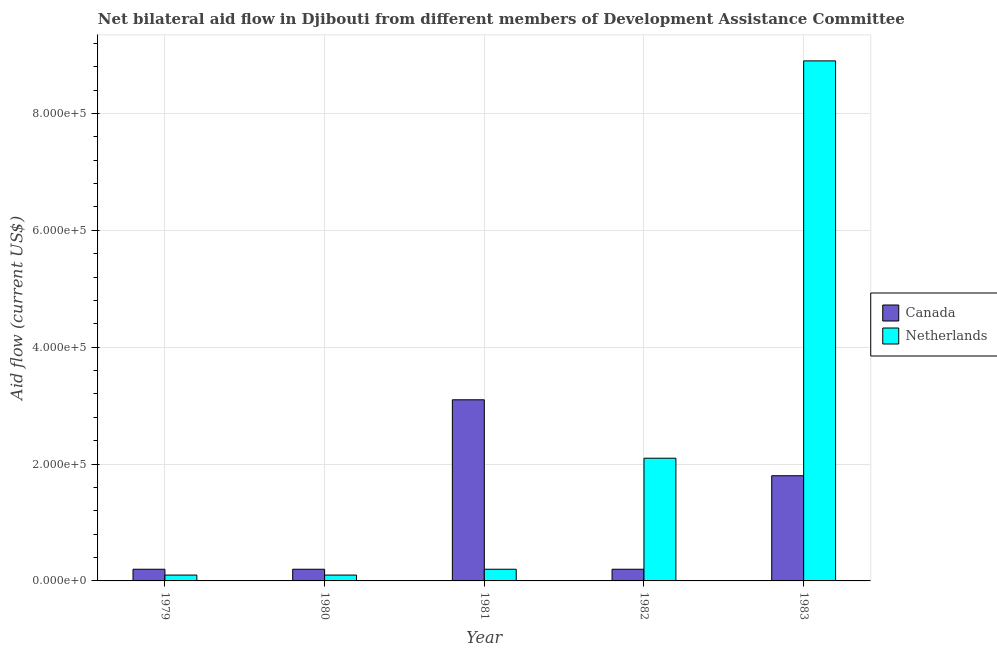How many different coloured bars are there?
Provide a succinct answer. 2. How many groups of bars are there?
Your answer should be compact. 5. Are the number of bars per tick equal to the number of legend labels?
Your answer should be very brief. Yes. Are the number of bars on each tick of the X-axis equal?
Give a very brief answer. Yes. In how many cases, is the number of bars for a given year not equal to the number of legend labels?
Offer a terse response. 0. What is the amount of aid given by netherlands in 1980?
Your answer should be very brief. 10000. Across all years, what is the maximum amount of aid given by netherlands?
Provide a succinct answer. 8.90e+05. Across all years, what is the minimum amount of aid given by canada?
Keep it short and to the point. 2.00e+04. In which year was the amount of aid given by canada maximum?
Ensure brevity in your answer.  1981. In which year was the amount of aid given by netherlands minimum?
Ensure brevity in your answer.  1979. What is the total amount of aid given by netherlands in the graph?
Your answer should be compact. 1.14e+06. What is the difference between the amount of aid given by canada in 1980 and the amount of aid given by netherlands in 1983?
Offer a terse response. -1.60e+05. What is the average amount of aid given by netherlands per year?
Your answer should be compact. 2.28e+05. In the year 1979, what is the difference between the amount of aid given by canada and amount of aid given by netherlands?
Offer a terse response. 0. In how many years, is the amount of aid given by canada greater than 320000 US$?
Provide a succinct answer. 0. What is the ratio of the amount of aid given by netherlands in 1979 to that in 1981?
Make the answer very short. 0.5. Is the amount of aid given by canada in 1982 less than that in 1983?
Give a very brief answer. Yes. What is the difference between the highest and the second highest amount of aid given by netherlands?
Offer a very short reply. 6.80e+05. What is the difference between the highest and the lowest amount of aid given by canada?
Keep it short and to the point. 2.90e+05. In how many years, is the amount of aid given by canada greater than the average amount of aid given by canada taken over all years?
Provide a short and direct response. 2. What does the 2nd bar from the left in 1982 represents?
Keep it short and to the point. Netherlands. What does the 1st bar from the right in 1980 represents?
Your response must be concise. Netherlands. Are all the bars in the graph horizontal?
Provide a short and direct response. No. How many years are there in the graph?
Give a very brief answer. 5. Does the graph contain grids?
Your response must be concise. Yes. What is the title of the graph?
Offer a terse response. Net bilateral aid flow in Djibouti from different members of Development Assistance Committee. Does "Female labourers" appear as one of the legend labels in the graph?
Offer a terse response. No. What is the label or title of the Y-axis?
Make the answer very short. Aid flow (current US$). What is the Aid flow (current US$) of Netherlands in 1979?
Your answer should be very brief. 10000. What is the Aid flow (current US$) of Netherlands in 1981?
Ensure brevity in your answer.  2.00e+04. What is the Aid flow (current US$) in Canada in 1982?
Your answer should be compact. 2.00e+04. What is the Aid flow (current US$) of Netherlands in 1982?
Ensure brevity in your answer.  2.10e+05. What is the Aid flow (current US$) in Netherlands in 1983?
Ensure brevity in your answer.  8.90e+05. Across all years, what is the maximum Aid flow (current US$) of Canada?
Offer a terse response. 3.10e+05. Across all years, what is the maximum Aid flow (current US$) in Netherlands?
Offer a terse response. 8.90e+05. Across all years, what is the minimum Aid flow (current US$) of Canada?
Your response must be concise. 2.00e+04. What is the total Aid flow (current US$) of Netherlands in the graph?
Offer a terse response. 1.14e+06. What is the difference between the Aid flow (current US$) of Canada in 1979 and that in 1980?
Ensure brevity in your answer.  0. What is the difference between the Aid flow (current US$) in Netherlands in 1979 and that in 1980?
Offer a terse response. 0. What is the difference between the Aid flow (current US$) in Canada in 1979 and that in 1981?
Keep it short and to the point. -2.90e+05. What is the difference between the Aid flow (current US$) in Netherlands in 1979 and that in 1982?
Keep it short and to the point. -2.00e+05. What is the difference between the Aid flow (current US$) in Canada in 1979 and that in 1983?
Your answer should be very brief. -1.60e+05. What is the difference between the Aid flow (current US$) in Netherlands in 1979 and that in 1983?
Your answer should be compact. -8.80e+05. What is the difference between the Aid flow (current US$) in Netherlands in 1980 and that in 1981?
Keep it short and to the point. -10000. What is the difference between the Aid flow (current US$) of Canada in 1980 and that in 1982?
Your response must be concise. 0. What is the difference between the Aid flow (current US$) of Canada in 1980 and that in 1983?
Offer a very short reply. -1.60e+05. What is the difference between the Aid flow (current US$) of Netherlands in 1980 and that in 1983?
Ensure brevity in your answer.  -8.80e+05. What is the difference between the Aid flow (current US$) in Netherlands in 1981 and that in 1982?
Make the answer very short. -1.90e+05. What is the difference between the Aid flow (current US$) in Canada in 1981 and that in 1983?
Ensure brevity in your answer.  1.30e+05. What is the difference between the Aid flow (current US$) of Netherlands in 1981 and that in 1983?
Your response must be concise. -8.70e+05. What is the difference between the Aid flow (current US$) in Netherlands in 1982 and that in 1983?
Your answer should be very brief. -6.80e+05. What is the difference between the Aid flow (current US$) in Canada in 1979 and the Aid flow (current US$) in Netherlands in 1980?
Provide a succinct answer. 10000. What is the difference between the Aid flow (current US$) in Canada in 1979 and the Aid flow (current US$) in Netherlands in 1981?
Your answer should be very brief. 0. What is the difference between the Aid flow (current US$) in Canada in 1979 and the Aid flow (current US$) in Netherlands in 1983?
Provide a short and direct response. -8.70e+05. What is the difference between the Aid flow (current US$) in Canada in 1980 and the Aid flow (current US$) in Netherlands in 1982?
Provide a short and direct response. -1.90e+05. What is the difference between the Aid flow (current US$) in Canada in 1980 and the Aid flow (current US$) in Netherlands in 1983?
Make the answer very short. -8.70e+05. What is the difference between the Aid flow (current US$) in Canada in 1981 and the Aid flow (current US$) in Netherlands in 1982?
Offer a very short reply. 1.00e+05. What is the difference between the Aid flow (current US$) of Canada in 1981 and the Aid flow (current US$) of Netherlands in 1983?
Keep it short and to the point. -5.80e+05. What is the difference between the Aid flow (current US$) in Canada in 1982 and the Aid flow (current US$) in Netherlands in 1983?
Provide a short and direct response. -8.70e+05. What is the average Aid flow (current US$) in Netherlands per year?
Your answer should be compact. 2.28e+05. In the year 1980, what is the difference between the Aid flow (current US$) in Canada and Aid flow (current US$) in Netherlands?
Give a very brief answer. 10000. In the year 1982, what is the difference between the Aid flow (current US$) of Canada and Aid flow (current US$) of Netherlands?
Your answer should be compact. -1.90e+05. In the year 1983, what is the difference between the Aid flow (current US$) in Canada and Aid flow (current US$) in Netherlands?
Offer a terse response. -7.10e+05. What is the ratio of the Aid flow (current US$) of Canada in 1979 to that in 1980?
Provide a succinct answer. 1. What is the ratio of the Aid flow (current US$) in Netherlands in 1979 to that in 1980?
Your answer should be very brief. 1. What is the ratio of the Aid flow (current US$) in Canada in 1979 to that in 1981?
Make the answer very short. 0.06. What is the ratio of the Aid flow (current US$) in Netherlands in 1979 to that in 1981?
Give a very brief answer. 0.5. What is the ratio of the Aid flow (current US$) of Netherlands in 1979 to that in 1982?
Provide a short and direct response. 0.05. What is the ratio of the Aid flow (current US$) of Netherlands in 1979 to that in 1983?
Ensure brevity in your answer.  0.01. What is the ratio of the Aid flow (current US$) in Canada in 1980 to that in 1981?
Provide a succinct answer. 0.06. What is the ratio of the Aid flow (current US$) of Netherlands in 1980 to that in 1981?
Keep it short and to the point. 0.5. What is the ratio of the Aid flow (current US$) of Netherlands in 1980 to that in 1982?
Make the answer very short. 0.05. What is the ratio of the Aid flow (current US$) in Netherlands in 1980 to that in 1983?
Give a very brief answer. 0.01. What is the ratio of the Aid flow (current US$) in Netherlands in 1981 to that in 1982?
Offer a terse response. 0.1. What is the ratio of the Aid flow (current US$) in Canada in 1981 to that in 1983?
Offer a terse response. 1.72. What is the ratio of the Aid flow (current US$) of Netherlands in 1981 to that in 1983?
Ensure brevity in your answer.  0.02. What is the ratio of the Aid flow (current US$) in Canada in 1982 to that in 1983?
Your answer should be very brief. 0.11. What is the ratio of the Aid flow (current US$) of Netherlands in 1982 to that in 1983?
Your answer should be very brief. 0.24. What is the difference between the highest and the second highest Aid flow (current US$) of Canada?
Give a very brief answer. 1.30e+05. What is the difference between the highest and the second highest Aid flow (current US$) of Netherlands?
Provide a short and direct response. 6.80e+05. What is the difference between the highest and the lowest Aid flow (current US$) in Canada?
Your answer should be compact. 2.90e+05. What is the difference between the highest and the lowest Aid flow (current US$) in Netherlands?
Give a very brief answer. 8.80e+05. 